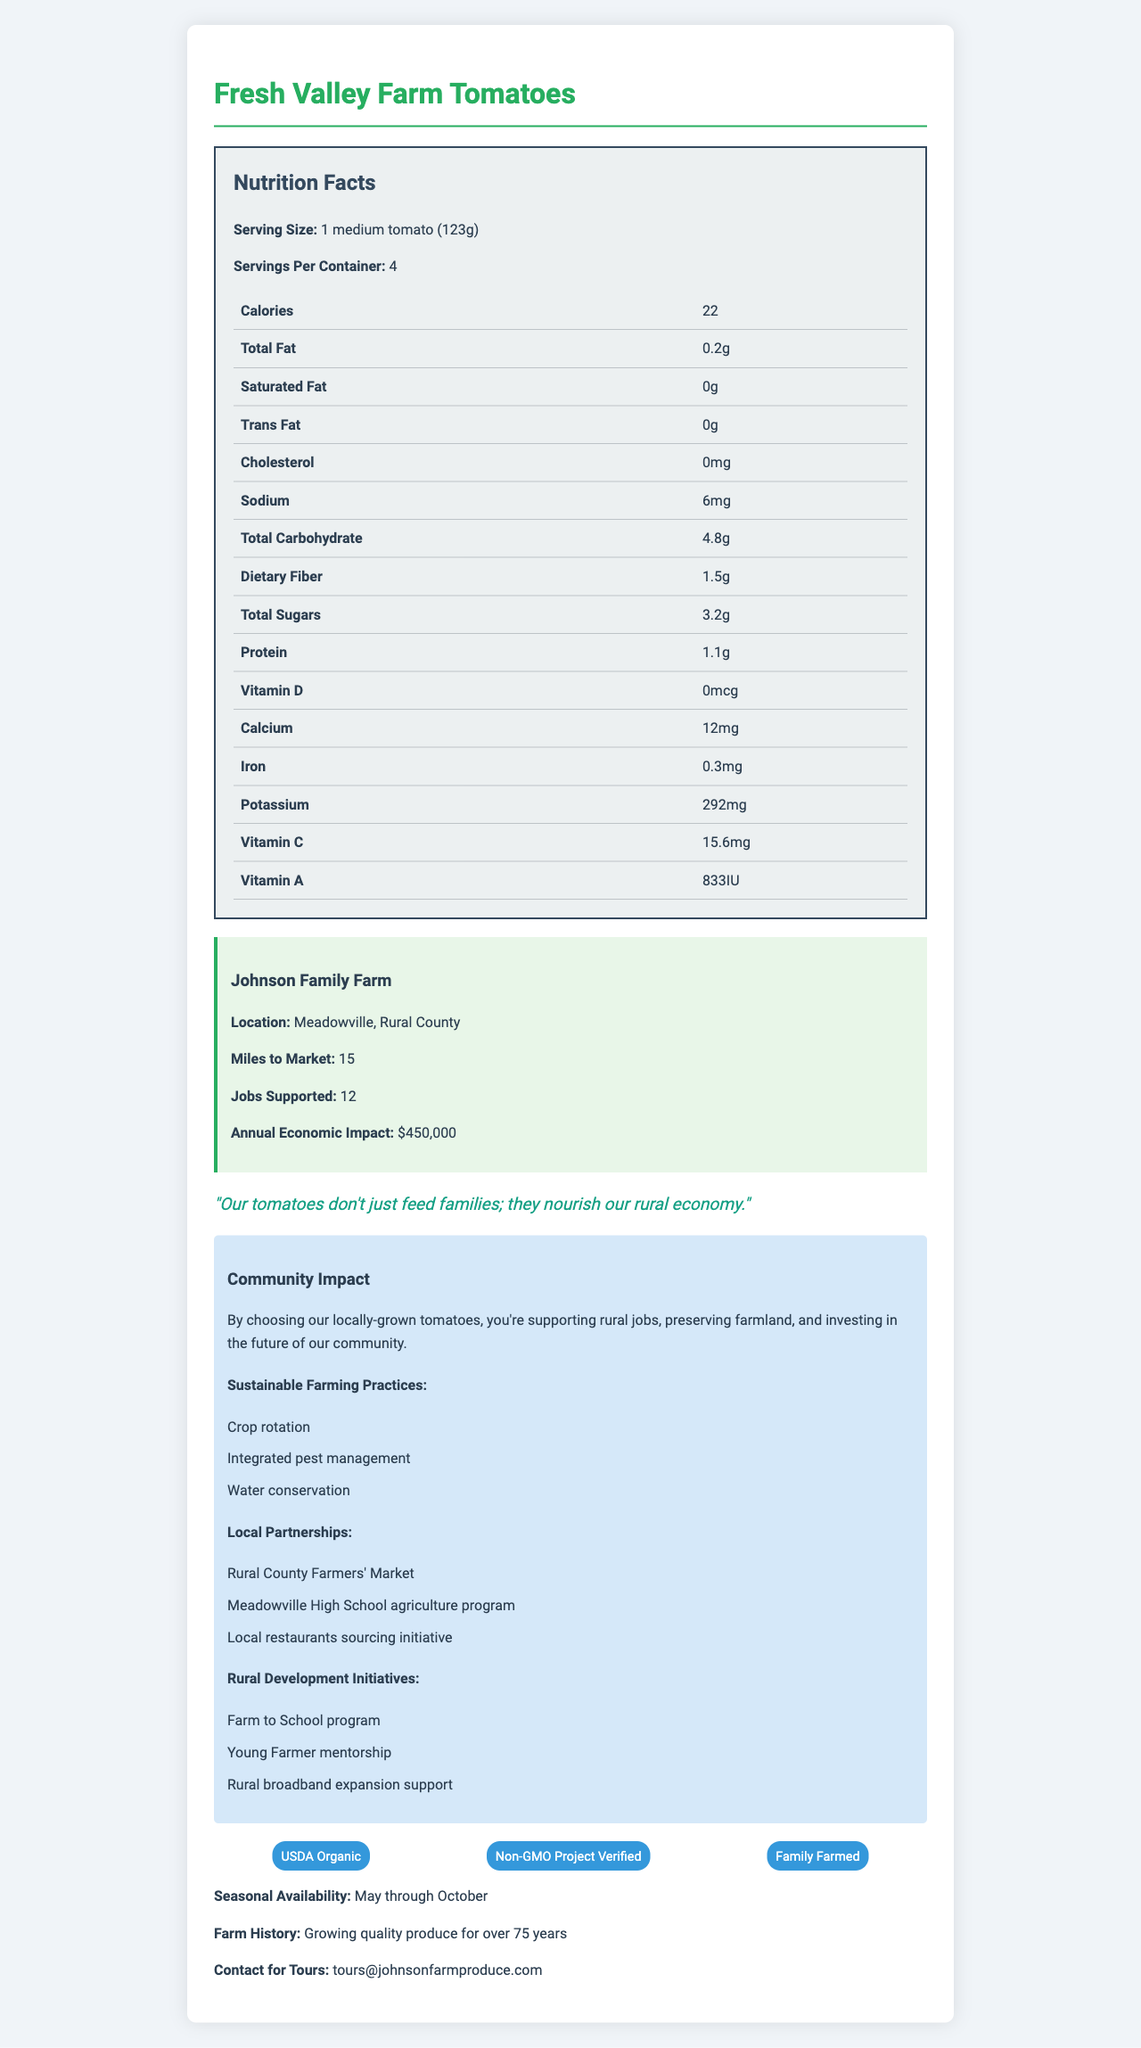what is the serving size? The serving size is mentioned in the Nutrition Facts section of the document.
Answer: 1 medium tomato (123g) How many calories are in one serving of Fresh Valley Farm Tomatoes? The number of calories per serving is listed in the Nutrition Facts section under Calories.
Answer: 22 calories What is the annual economic impact of Johnson Family Farm? The annual economic impact is stated in the farm information section as $450,000.
Answer: $450,000 Where is the Johnson Family Farm located? The farm location is specified in the farm information section.
Answer: Meadowville, Rural County How many jobs does Johnson Family Farm support? The number of jobs supported is listed in the farm information section.
Answer: 12 jobs Which of the following is NOT listed under sustainable farming practices? A. Crop rotation B. Organic fertilizers C. Integrated pest management D. Water conservation Organic fertilizers are not listed under sustainable farming practices in the document.
Answer: B. Organic fertilizers How far is the farm from the market? A. 10 miles B. 15 miles C. 20 miles The farm's distance to the market is listed as 15 miles in the farm information section.
Answer: B. 15 miles Is there any cholesterol in Fresh Valley Farm Tomatoes? The Nutrition Facts section lists cholesterol as 0mg, indicating there is no cholesterol.
Answer: No Summarize the main idea of the document. The document's main idea includes nutritional details of the tomatoes and the significant role of Johnson Family Farm in supporting rural jobs and using sustainable practices. Local community benefits and various initiatives are also highlighted.
Answer: The document provides detailed nutritional information about Fresh Valley Farm Tomatoes and highlights the rural economic and community impact of Johnson Family Farm. It emphasizes their sustainable farming practices, local partnerships, and rural development initiatives, while also promoting local economic benefits and job support. What is the sodium content per serving? The sodium content per serving is listed as 6mg in the Nutrition Facts section.
Answer: 6mg What are the certifications held by Johnson Family Farm? The certifications are listed at the bottom of the document under the certifications section.
Answer: USDA Organic, Non-GMO Project Verified, Family Farmed What vitamin is present in the highest amount in Fresh Valley Farm Tomatoes? A. Vitamin D B. Calcium C. Vitamin C D. Vitamin A The Nutrition Facts section lists 833IU of Vitamin A, which is higher than the amounts listed for other vitamins.
Answer: D. Vitamin A What is the potassium content per serving? The potassium content per serving is listed as 292mg in the Nutrition Facts section.
Answer: 292mg What local partnership is mentioned in the document? These partnerships are listed in the local partnerships section of the document.
Answer: Rural County Farmers' Market, Meadowville High School agriculture program, Local restaurants sourcing initiative What is the history of the farm? The farm history is stated as growing quality produce for over 75 years.
Answer: Growing quality produce for over 75 years What are the rural development initiatives supported by Johnson Family Farm? These initiatives are mentioned in the rural development initiatives section of the document.
Answer: Farm to School program, Young Farmer mentorship, Rural broadband expansion support What kind of farming practices does Johnson Family Farm use? These sustainable farming practices are listed in the sustainable farming practices section.
Answer: Crop rotation, Integrated pest management, Water conservation When are Fresh Valley Farm Tomatoes seasonally available? The seasonal availability is mentioned as May through October in the document.
Answer: May through October What is the protein content per serving of the tomatoes? The protein content per serving is listed as 1.1g in the Nutrition Facts section.
Answer: 1.1g How many servings are there per container? The servings per container are listed as 4 in the Nutrition Facts section.
Answer: 4 What is the email for contacting farm tours? The email for contacting farm tours is provided at the bottom of the document.
Answer: tours@johnsonfarmproduce.com What is the total carbohydrate content per serving? The total carbohydrate content per serving is listed as 4.8g in the Nutrition Facts section.
Answer: 4.8g How many grams of dietary fiber are in one serving of Fresh Valley Farm Tomatoes? The dietary fiber content per serving is listed as 1.5g in the Nutrition Facts section.
Answer: 1.5g What is the stance of Johnson Family Farm regarding GMOs? The document does not explicitly state the farm's stance on GMOs, although it does mention having Non-GMO Project Verified certification, which implies non-GMO practices. However, the stance itself is not clearly stated.
Answer: Not enough information 